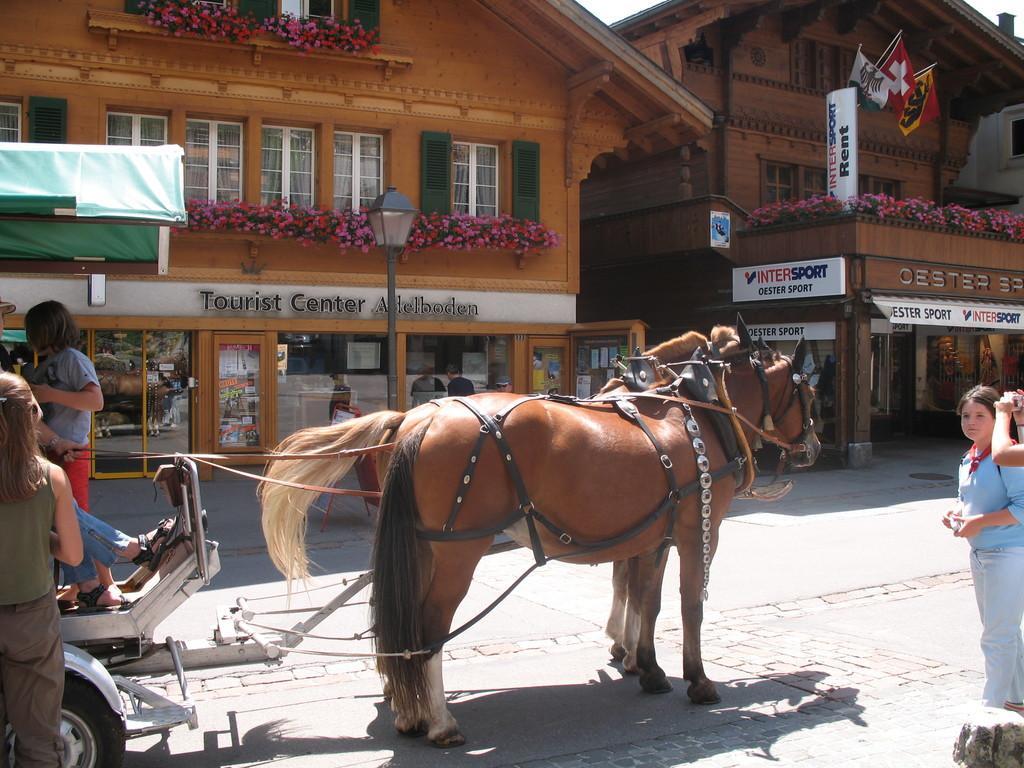Describe this image in one or two sentences. In the background we can see buildings. In this picture we can see flowers, windows, flags, boards, stores, people, cart, animals, light pole and objects. On the right side of the picture we can see a person's hand holding an object. 